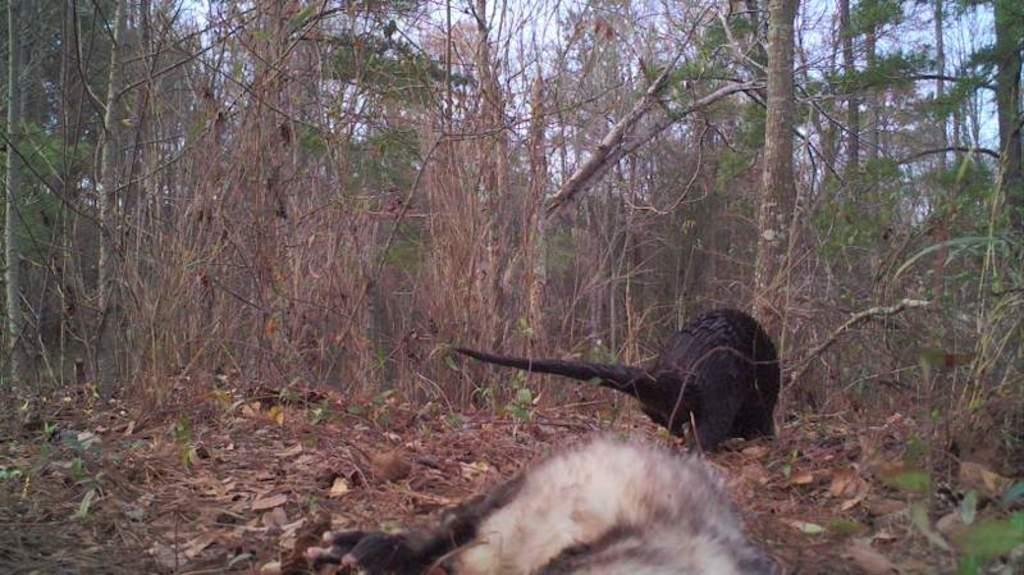What is the setting of the image? The image is taken in a forest. How many animals can be seen in the image? There are two animals in the front of the image. What can be found at the bottom of the image? Dried leaves are present at the bottom of the image. What is visible in the background of the image? There are many trees in the background of the image. What is the belief system of the animals in the image? There is no information about the belief system of the animals in the image. What route do the animals take to reach the forest in the image? The image does not show the animals arriving at the forest, so we cannot determine their route. 